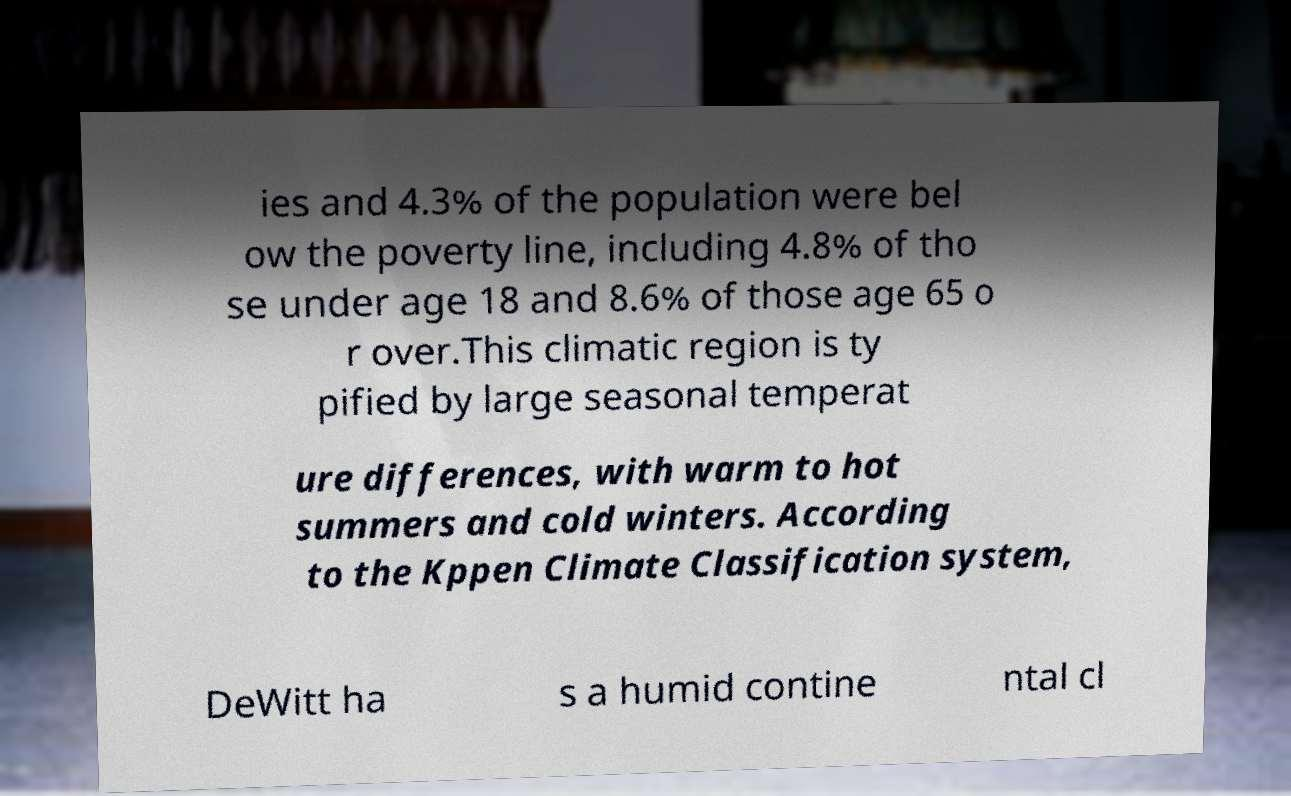Can you accurately transcribe the text from the provided image for me? ies and 4.3% of the population were bel ow the poverty line, including 4.8% of tho se under age 18 and 8.6% of those age 65 o r over.This climatic region is ty pified by large seasonal temperat ure differences, with warm to hot summers and cold winters. According to the Kppen Climate Classification system, DeWitt ha s a humid contine ntal cl 